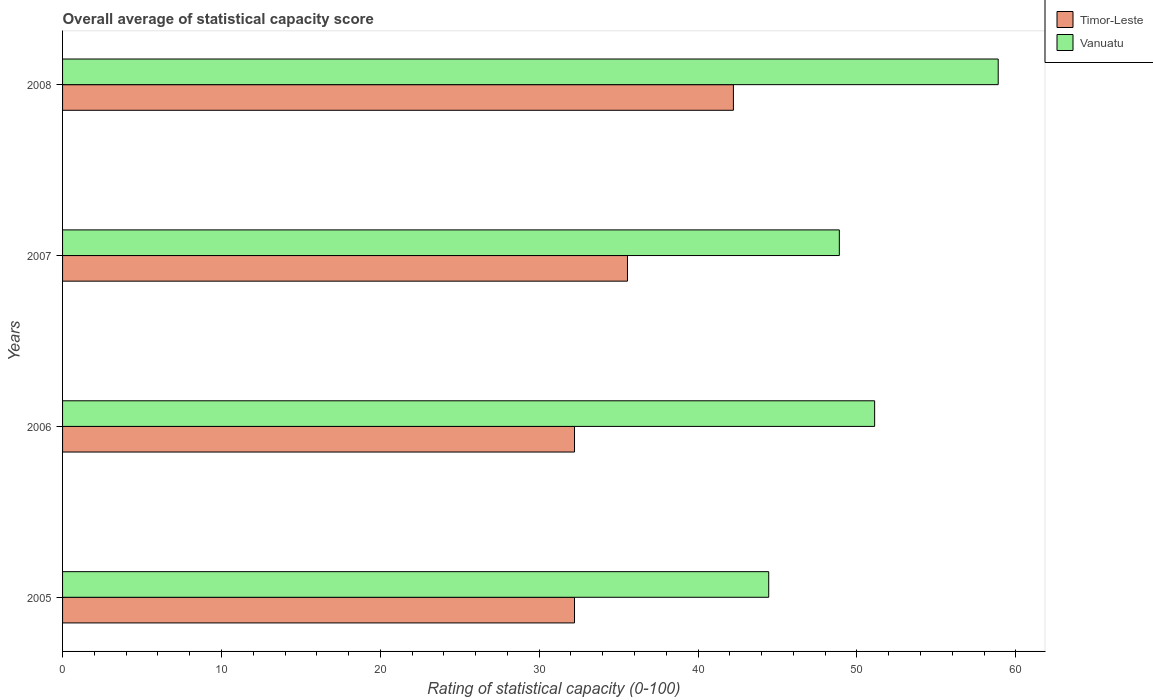How many different coloured bars are there?
Offer a very short reply. 2. How many groups of bars are there?
Your answer should be very brief. 4. In how many cases, is the number of bars for a given year not equal to the number of legend labels?
Give a very brief answer. 0. What is the rating of statistical capacity in Timor-Leste in 2006?
Keep it short and to the point. 32.22. Across all years, what is the maximum rating of statistical capacity in Vanuatu?
Your answer should be very brief. 58.89. Across all years, what is the minimum rating of statistical capacity in Vanuatu?
Provide a succinct answer. 44.44. In which year was the rating of statistical capacity in Vanuatu minimum?
Your answer should be very brief. 2005. What is the total rating of statistical capacity in Timor-Leste in the graph?
Offer a terse response. 142.22. What is the difference between the rating of statistical capacity in Vanuatu in 2006 and the rating of statistical capacity in Timor-Leste in 2005?
Ensure brevity in your answer.  18.89. What is the average rating of statistical capacity in Vanuatu per year?
Your answer should be very brief. 50.83. In the year 2007, what is the difference between the rating of statistical capacity in Timor-Leste and rating of statistical capacity in Vanuatu?
Offer a very short reply. -13.33. What is the ratio of the rating of statistical capacity in Vanuatu in 2006 to that in 2007?
Make the answer very short. 1.05. What is the difference between the highest and the second highest rating of statistical capacity in Timor-Leste?
Keep it short and to the point. 6.67. What is the difference between the highest and the lowest rating of statistical capacity in Timor-Leste?
Offer a very short reply. 10. In how many years, is the rating of statistical capacity in Vanuatu greater than the average rating of statistical capacity in Vanuatu taken over all years?
Ensure brevity in your answer.  2. What does the 1st bar from the top in 2007 represents?
Provide a short and direct response. Vanuatu. What does the 1st bar from the bottom in 2005 represents?
Offer a terse response. Timor-Leste. How many bars are there?
Your response must be concise. 8. Are all the bars in the graph horizontal?
Give a very brief answer. Yes. How many years are there in the graph?
Give a very brief answer. 4. What is the difference between two consecutive major ticks on the X-axis?
Provide a short and direct response. 10. Does the graph contain any zero values?
Offer a very short reply. No. Does the graph contain grids?
Make the answer very short. No. Where does the legend appear in the graph?
Provide a succinct answer. Top right. How many legend labels are there?
Ensure brevity in your answer.  2. What is the title of the graph?
Your answer should be compact. Overall average of statistical capacity score. What is the label or title of the X-axis?
Make the answer very short. Rating of statistical capacity (0-100). What is the label or title of the Y-axis?
Keep it short and to the point. Years. What is the Rating of statistical capacity (0-100) of Timor-Leste in 2005?
Make the answer very short. 32.22. What is the Rating of statistical capacity (0-100) of Vanuatu in 2005?
Your response must be concise. 44.44. What is the Rating of statistical capacity (0-100) of Timor-Leste in 2006?
Keep it short and to the point. 32.22. What is the Rating of statistical capacity (0-100) of Vanuatu in 2006?
Provide a short and direct response. 51.11. What is the Rating of statistical capacity (0-100) in Timor-Leste in 2007?
Offer a very short reply. 35.56. What is the Rating of statistical capacity (0-100) of Vanuatu in 2007?
Provide a short and direct response. 48.89. What is the Rating of statistical capacity (0-100) of Timor-Leste in 2008?
Make the answer very short. 42.22. What is the Rating of statistical capacity (0-100) of Vanuatu in 2008?
Keep it short and to the point. 58.89. Across all years, what is the maximum Rating of statistical capacity (0-100) in Timor-Leste?
Offer a terse response. 42.22. Across all years, what is the maximum Rating of statistical capacity (0-100) in Vanuatu?
Provide a short and direct response. 58.89. Across all years, what is the minimum Rating of statistical capacity (0-100) in Timor-Leste?
Ensure brevity in your answer.  32.22. Across all years, what is the minimum Rating of statistical capacity (0-100) in Vanuatu?
Provide a succinct answer. 44.44. What is the total Rating of statistical capacity (0-100) of Timor-Leste in the graph?
Give a very brief answer. 142.22. What is the total Rating of statistical capacity (0-100) in Vanuatu in the graph?
Give a very brief answer. 203.33. What is the difference between the Rating of statistical capacity (0-100) of Timor-Leste in 2005 and that in 2006?
Your answer should be compact. 0. What is the difference between the Rating of statistical capacity (0-100) of Vanuatu in 2005 and that in 2006?
Your answer should be very brief. -6.67. What is the difference between the Rating of statistical capacity (0-100) in Timor-Leste in 2005 and that in 2007?
Ensure brevity in your answer.  -3.33. What is the difference between the Rating of statistical capacity (0-100) of Vanuatu in 2005 and that in 2007?
Keep it short and to the point. -4.44. What is the difference between the Rating of statistical capacity (0-100) in Vanuatu in 2005 and that in 2008?
Your answer should be compact. -14.44. What is the difference between the Rating of statistical capacity (0-100) of Timor-Leste in 2006 and that in 2007?
Keep it short and to the point. -3.33. What is the difference between the Rating of statistical capacity (0-100) of Vanuatu in 2006 and that in 2007?
Make the answer very short. 2.22. What is the difference between the Rating of statistical capacity (0-100) of Vanuatu in 2006 and that in 2008?
Give a very brief answer. -7.78. What is the difference between the Rating of statistical capacity (0-100) in Timor-Leste in 2007 and that in 2008?
Offer a terse response. -6.67. What is the difference between the Rating of statistical capacity (0-100) in Timor-Leste in 2005 and the Rating of statistical capacity (0-100) in Vanuatu in 2006?
Your answer should be very brief. -18.89. What is the difference between the Rating of statistical capacity (0-100) of Timor-Leste in 2005 and the Rating of statistical capacity (0-100) of Vanuatu in 2007?
Your response must be concise. -16.67. What is the difference between the Rating of statistical capacity (0-100) in Timor-Leste in 2005 and the Rating of statistical capacity (0-100) in Vanuatu in 2008?
Provide a short and direct response. -26.67. What is the difference between the Rating of statistical capacity (0-100) of Timor-Leste in 2006 and the Rating of statistical capacity (0-100) of Vanuatu in 2007?
Offer a very short reply. -16.67. What is the difference between the Rating of statistical capacity (0-100) of Timor-Leste in 2006 and the Rating of statistical capacity (0-100) of Vanuatu in 2008?
Provide a short and direct response. -26.67. What is the difference between the Rating of statistical capacity (0-100) of Timor-Leste in 2007 and the Rating of statistical capacity (0-100) of Vanuatu in 2008?
Offer a terse response. -23.33. What is the average Rating of statistical capacity (0-100) in Timor-Leste per year?
Give a very brief answer. 35.56. What is the average Rating of statistical capacity (0-100) in Vanuatu per year?
Your response must be concise. 50.83. In the year 2005, what is the difference between the Rating of statistical capacity (0-100) of Timor-Leste and Rating of statistical capacity (0-100) of Vanuatu?
Ensure brevity in your answer.  -12.22. In the year 2006, what is the difference between the Rating of statistical capacity (0-100) in Timor-Leste and Rating of statistical capacity (0-100) in Vanuatu?
Make the answer very short. -18.89. In the year 2007, what is the difference between the Rating of statistical capacity (0-100) of Timor-Leste and Rating of statistical capacity (0-100) of Vanuatu?
Provide a succinct answer. -13.33. In the year 2008, what is the difference between the Rating of statistical capacity (0-100) in Timor-Leste and Rating of statistical capacity (0-100) in Vanuatu?
Provide a succinct answer. -16.67. What is the ratio of the Rating of statistical capacity (0-100) of Timor-Leste in 2005 to that in 2006?
Give a very brief answer. 1. What is the ratio of the Rating of statistical capacity (0-100) in Vanuatu in 2005 to that in 2006?
Offer a very short reply. 0.87. What is the ratio of the Rating of statistical capacity (0-100) of Timor-Leste in 2005 to that in 2007?
Your answer should be very brief. 0.91. What is the ratio of the Rating of statistical capacity (0-100) in Timor-Leste in 2005 to that in 2008?
Ensure brevity in your answer.  0.76. What is the ratio of the Rating of statistical capacity (0-100) in Vanuatu in 2005 to that in 2008?
Your response must be concise. 0.75. What is the ratio of the Rating of statistical capacity (0-100) in Timor-Leste in 2006 to that in 2007?
Offer a terse response. 0.91. What is the ratio of the Rating of statistical capacity (0-100) in Vanuatu in 2006 to that in 2007?
Your response must be concise. 1.05. What is the ratio of the Rating of statistical capacity (0-100) of Timor-Leste in 2006 to that in 2008?
Keep it short and to the point. 0.76. What is the ratio of the Rating of statistical capacity (0-100) in Vanuatu in 2006 to that in 2008?
Make the answer very short. 0.87. What is the ratio of the Rating of statistical capacity (0-100) of Timor-Leste in 2007 to that in 2008?
Offer a terse response. 0.84. What is the ratio of the Rating of statistical capacity (0-100) of Vanuatu in 2007 to that in 2008?
Offer a very short reply. 0.83. What is the difference between the highest and the second highest Rating of statistical capacity (0-100) of Timor-Leste?
Offer a terse response. 6.67. What is the difference between the highest and the second highest Rating of statistical capacity (0-100) of Vanuatu?
Keep it short and to the point. 7.78. What is the difference between the highest and the lowest Rating of statistical capacity (0-100) of Timor-Leste?
Provide a short and direct response. 10. What is the difference between the highest and the lowest Rating of statistical capacity (0-100) of Vanuatu?
Provide a succinct answer. 14.44. 